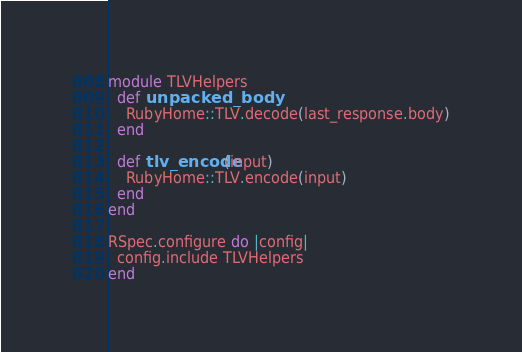<code> <loc_0><loc_0><loc_500><loc_500><_Ruby_>module TLVHelpers
  def unpacked_body
    RubyHome::TLV.decode(last_response.body)
  end

  def tlv_encode(input)
    RubyHome::TLV.encode(input)
  end
end

RSpec.configure do |config|
  config.include TLVHelpers
end
</code> 